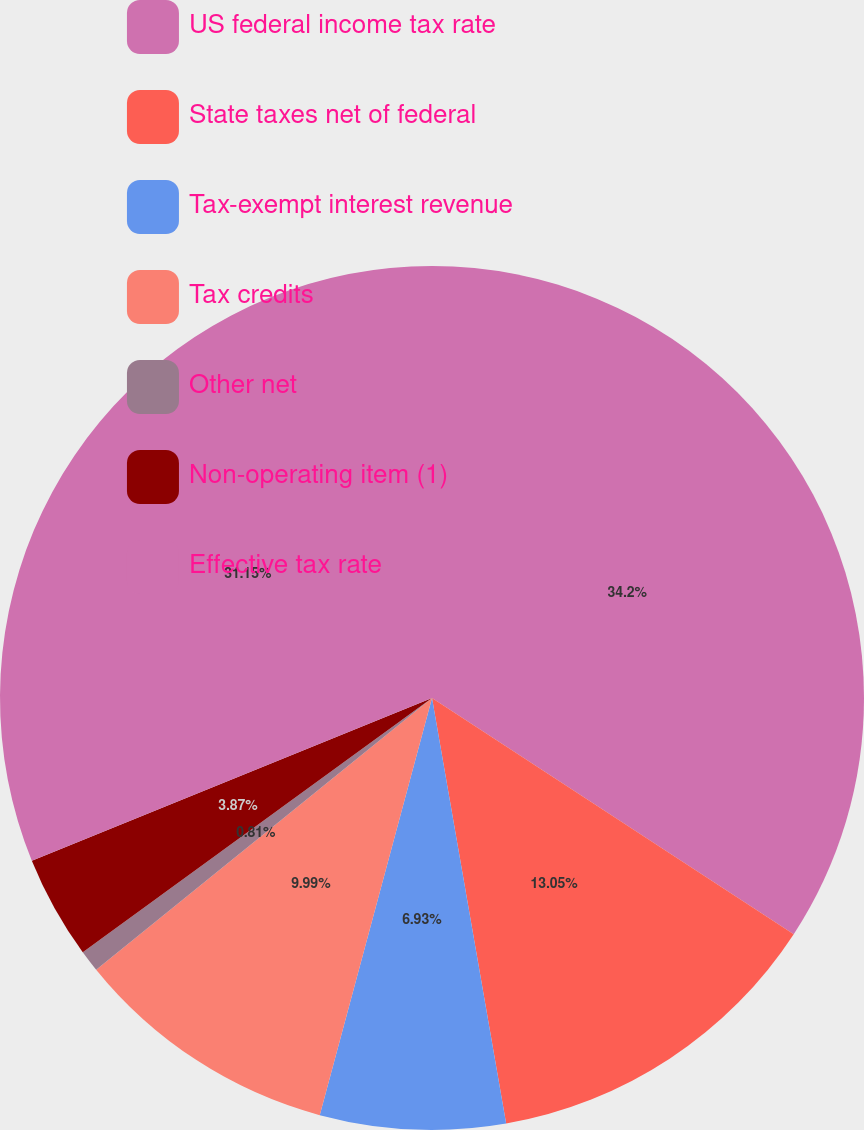<chart> <loc_0><loc_0><loc_500><loc_500><pie_chart><fcel>US federal income tax rate<fcel>State taxes net of federal<fcel>Tax-exempt interest revenue<fcel>Tax credits<fcel>Other net<fcel>Non-operating item (1)<fcel>Effective tax rate<nl><fcel>34.21%<fcel>13.05%<fcel>6.93%<fcel>9.99%<fcel>0.81%<fcel>3.87%<fcel>31.15%<nl></chart> 